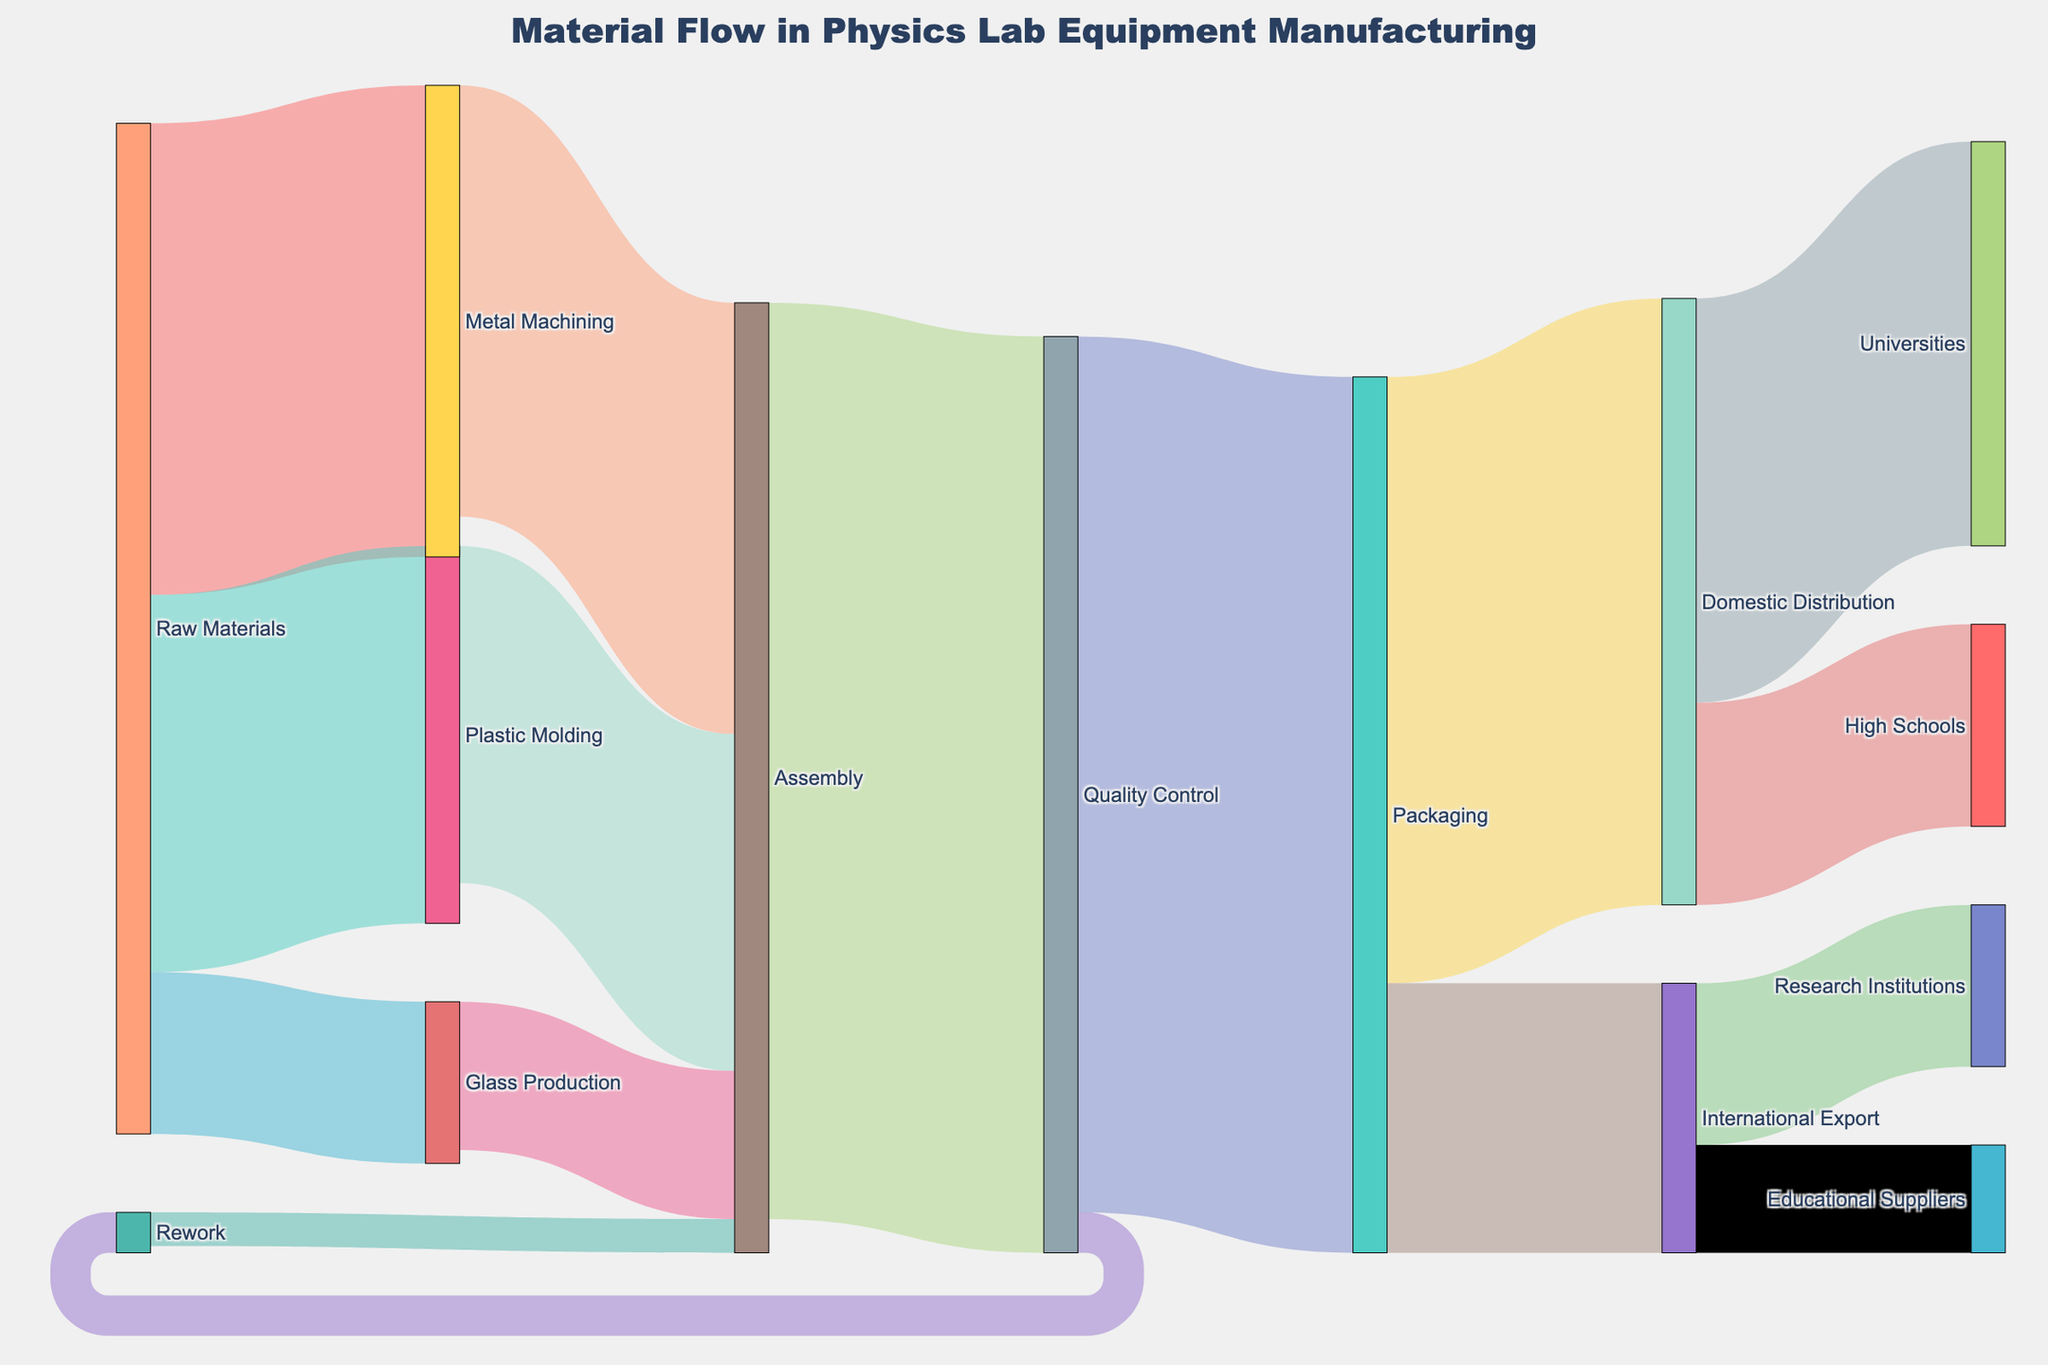What is the total value of flow from Raw Materials to Assembly? The flow from Raw Materials needs to be split into its respective processes and then summed after they reach Assembly:
Raw Materials to Metal Machining = 350,
Raw Materials to Plastic Molding = 280,
Raw Materials to Glass Production = 120.
These totals move to Assembly as:
Metal Machining to Assembly = 320,
Plastic Molding to Assembly = 250,
Glass Production to Assembly = 110.
Sum these values: 320 + 250 + 110 = 680.
Answer: 680 What process receives the highest material flow from Quality Control? Observe the connections from Quality Control to other processes. Quality Control flows to Packaging (650), and Rework (30). Packaging has the highest value.
Answer: Packaging Which distribution channel has the most material flow from Packaging? Packaging flows into Domestic Distribution (450) and International Export (200). Compare these values, Domestic Distribution is higher.
Answer: Domestic Distribution What is the total material flow from Assembly to Quality Control and Rework combined? From the diagram, Assembly flows into Quality Control (680). This is the value needed since Assembly does not flow directly into Rework. Instead, Rework is only reached after Quality Control. So, the direct flow from Assembly in this case is only to Quality Control: 680
Answer: 680 How much material is reworked in the entire process? Identify the flow that mentions Rework. Quality Control to Rework (30) and Rework back to Assembly (25). Only 30 is the relevant initial rework value. The flow back into Assembly does not double count it.
Answer: 30 What is the combined flow of materials to schools and universities? Observe the distribution from Domestic Distribution:
Domestic Distribution to Universities = 300,
Domestic Distribution to High Schools = 150.
Sum these values: 300 + 150 = 450.
Answer: 450 How does the flow to Research Institutions compare to Educational Suppliers? From International Export, the flow to Research Institutions is 120 and the flow to Educational Suppliers is 80. Research Institutions is greater.
Answer: Research Institutions What can be inferred about the flow of materials from Rework to Assembly compared to the flow from Quality Control to Rework? Flow from Rework to Assembly is 25, while the flow from Quality Control to Rework is 30. Quality Control to Rework has a higher value.
Answer: Quality Control to Rework is higher How much material is left after quality control, not requiring rework? From Quality Control, the total initial flow is 680. Subtract the rework flow (30). The remaining is: 680 - 30 = 650.
Answer: 650 